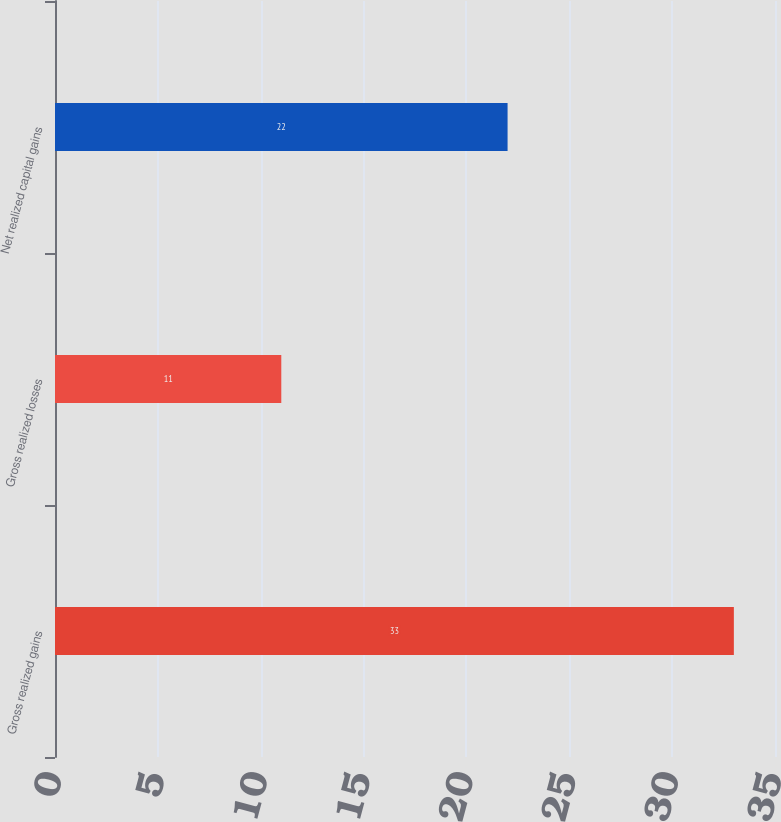<chart> <loc_0><loc_0><loc_500><loc_500><bar_chart><fcel>Gross realized gains<fcel>Gross realized losses<fcel>Net realized capital gains<nl><fcel>33<fcel>11<fcel>22<nl></chart> 